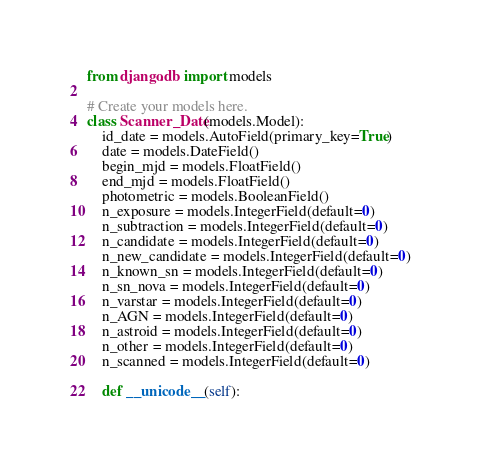<code> <loc_0><loc_0><loc_500><loc_500><_Python_>from django.db import models

# Create your models here.
class Scanner_Date(models.Model):
    id_date = models.AutoField(primary_key=True)
    date = models.DateField()
    begin_mjd = models.FloatField()
    end_mjd = models.FloatField()
    photometric = models.BooleanField()
    n_exposure = models.IntegerField(default=0)
    n_subtraction = models.IntegerField(default=0)
    n_candidate = models.IntegerField(default=0)
    n_new_candidate = models.IntegerField(default=0)
    n_known_sn = models.IntegerField(default=0)
    n_sn_nova = models.IntegerField(default=0)
    n_varstar = models.IntegerField(default=0)
    n_AGN = models.IntegerField(default=0)
    n_astroid = models.IntegerField(default=0)
    n_other = models.IntegerField(default=0)
    n_scanned = models.IntegerField(default=0)
    
    def __unicode__(self):</code> 